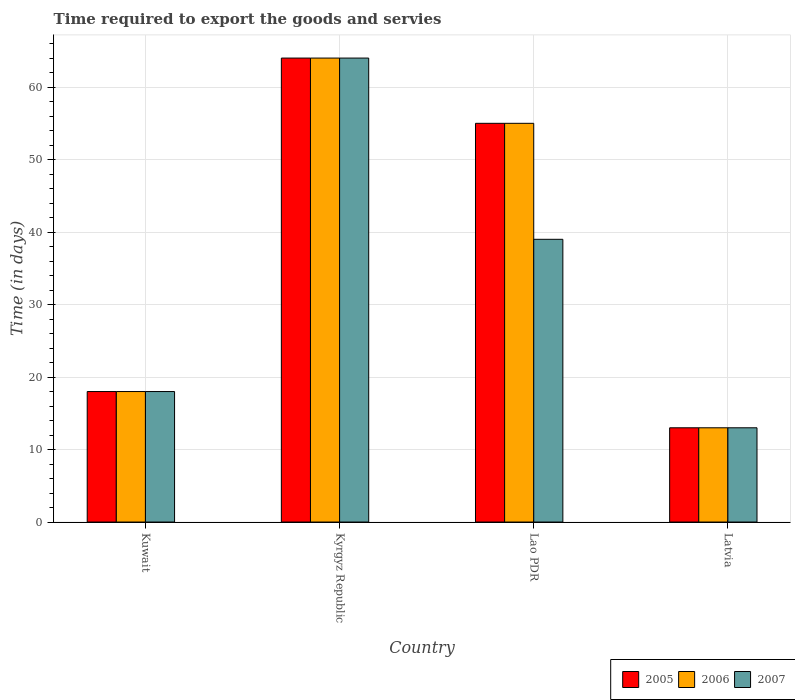How many different coloured bars are there?
Keep it short and to the point. 3. How many groups of bars are there?
Offer a very short reply. 4. Are the number of bars per tick equal to the number of legend labels?
Your response must be concise. Yes. Are the number of bars on each tick of the X-axis equal?
Give a very brief answer. Yes. How many bars are there on the 1st tick from the left?
Your response must be concise. 3. What is the label of the 4th group of bars from the left?
Offer a very short reply. Latvia. What is the number of days required to export the goods and services in 2006 in Lao PDR?
Keep it short and to the point. 55. Across all countries, what is the minimum number of days required to export the goods and services in 2005?
Provide a succinct answer. 13. In which country was the number of days required to export the goods and services in 2006 maximum?
Provide a succinct answer. Kyrgyz Republic. In which country was the number of days required to export the goods and services in 2006 minimum?
Your answer should be very brief. Latvia. What is the total number of days required to export the goods and services in 2007 in the graph?
Keep it short and to the point. 134. What is the difference between the number of days required to export the goods and services in 2006 in Kyrgyz Republic and that in Lao PDR?
Your response must be concise. 9. What is the difference between the number of days required to export the goods and services in 2007 in Latvia and the number of days required to export the goods and services in 2006 in Kyrgyz Republic?
Ensure brevity in your answer.  -51. What is the average number of days required to export the goods and services in 2007 per country?
Offer a terse response. 33.5. What is the difference between the number of days required to export the goods and services of/in 2007 and number of days required to export the goods and services of/in 2005 in Lao PDR?
Your answer should be compact. -16. What is the ratio of the number of days required to export the goods and services in 2007 in Kuwait to that in Latvia?
Offer a very short reply. 1.38. Is the difference between the number of days required to export the goods and services in 2007 in Kuwait and Latvia greater than the difference between the number of days required to export the goods and services in 2005 in Kuwait and Latvia?
Offer a terse response. No. What is the difference between the highest and the second highest number of days required to export the goods and services in 2005?
Ensure brevity in your answer.  46. What is the difference between the highest and the lowest number of days required to export the goods and services in 2005?
Your answer should be compact. 51. In how many countries, is the number of days required to export the goods and services in 2006 greater than the average number of days required to export the goods and services in 2006 taken over all countries?
Offer a very short reply. 2. Is the sum of the number of days required to export the goods and services in 2005 in Kuwait and Lao PDR greater than the maximum number of days required to export the goods and services in 2006 across all countries?
Your answer should be very brief. Yes. What does the 3rd bar from the left in Kyrgyz Republic represents?
Give a very brief answer. 2007. How many bars are there?
Keep it short and to the point. 12. Are all the bars in the graph horizontal?
Ensure brevity in your answer.  No. What is the difference between two consecutive major ticks on the Y-axis?
Your answer should be very brief. 10. Does the graph contain any zero values?
Ensure brevity in your answer.  No. Does the graph contain grids?
Give a very brief answer. Yes. Where does the legend appear in the graph?
Ensure brevity in your answer.  Bottom right. How are the legend labels stacked?
Provide a succinct answer. Horizontal. What is the title of the graph?
Provide a succinct answer. Time required to export the goods and servies. Does "1993" appear as one of the legend labels in the graph?
Your response must be concise. No. What is the label or title of the Y-axis?
Give a very brief answer. Time (in days). What is the Time (in days) in 2005 in Kuwait?
Give a very brief answer. 18. What is the Time (in days) of 2006 in Kuwait?
Your answer should be very brief. 18. What is the Time (in days) in 2007 in Kuwait?
Your response must be concise. 18. What is the Time (in days) in 2005 in Lao PDR?
Your response must be concise. 55. What is the Time (in days) in 2006 in Lao PDR?
Your response must be concise. 55. What is the Time (in days) of 2006 in Latvia?
Offer a very short reply. 13. What is the Time (in days) of 2007 in Latvia?
Your answer should be very brief. 13. Across all countries, what is the maximum Time (in days) in 2007?
Make the answer very short. 64. Across all countries, what is the minimum Time (in days) of 2005?
Give a very brief answer. 13. Across all countries, what is the minimum Time (in days) in 2006?
Your answer should be very brief. 13. What is the total Time (in days) of 2005 in the graph?
Ensure brevity in your answer.  150. What is the total Time (in days) in 2006 in the graph?
Your response must be concise. 150. What is the total Time (in days) of 2007 in the graph?
Keep it short and to the point. 134. What is the difference between the Time (in days) of 2005 in Kuwait and that in Kyrgyz Republic?
Offer a very short reply. -46. What is the difference between the Time (in days) in 2006 in Kuwait and that in Kyrgyz Republic?
Keep it short and to the point. -46. What is the difference between the Time (in days) of 2007 in Kuwait and that in Kyrgyz Republic?
Keep it short and to the point. -46. What is the difference between the Time (in days) of 2005 in Kuwait and that in Lao PDR?
Give a very brief answer. -37. What is the difference between the Time (in days) of 2006 in Kuwait and that in Lao PDR?
Offer a very short reply. -37. What is the difference between the Time (in days) in 2007 in Kuwait and that in Lao PDR?
Make the answer very short. -21. What is the difference between the Time (in days) of 2006 in Kuwait and that in Latvia?
Ensure brevity in your answer.  5. What is the difference between the Time (in days) in 2005 in Kyrgyz Republic and that in Lao PDR?
Make the answer very short. 9. What is the difference between the Time (in days) in 2007 in Kyrgyz Republic and that in Lao PDR?
Offer a very short reply. 25. What is the difference between the Time (in days) of 2005 in Kyrgyz Republic and that in Latvia?
Your answer should be compact. 51. What is the difference between the Time (in days) of 2006 in Kyrgyz Republic and that in Latvia?
Offer a terse response. 51. What is the difference between the Time (in days) of 2007 in Lao PDR and that in Latvia?
Keep it short and to the point. 26. What is the difference between the Time (in days) of 2005 in Kuwait and the Time (in days) of 2006 in Kyrgyz Republic?
Offer a terse response. -46. What is the difference between the Time (in days) of 2005 in Kuwait and the Time (in days) of 2007 in Kyrgyz Republic?
Ensure brevity in your answer.  -46. What is the difference between the Time (in days) in 2006 in Kuwait and the Time (in days) in 2007 in Kyrgyz Republic?
Offer a terse response. -46. What is the difference between the Time (in days) of 2005 in Kuwait and the Time (in days) of 2006 in Lao PDR?
Provide a succinct answer. -37. What is the difference between the Time (in days) of 2005 in Kuwait and the Time (in days) of 2007 in Lao PDR?
Offer a very short reply. -21. What is the difference between the Time (in days) in 2006 in Kuwait and the Time (in days) in 2007 in Lao PDR?
Your answer should be very brief. -21. What is the difference between the Time (in days) of 2006 in Kuwait and the Time (in days) of 2007 in Latvia?
Provide a succinct answer. 5. What is the difference between the Time (in days) of 2005 in Kyrgyz Republic and the Time (in days) of 2006 in Lao PDR?
Offer a very short reply. 9. What is the difference between the Time (in days) in 2005 in Kyrgyz Republic and the Time (in days) in 2006 in Latvia?
Make the answer very short. 51. What is the difference between the Time (in days) of 2006 in Kyrgyz Republic and the Time (in days) of 2007 in Latvia?
Provide a short and direct response. 51. What is the difference between the Time (in days) of 2005 in Lao PDR and the Time (in days) of 2007 in Latvia?
Keep it short and to the point. 42. What is the difference between the Time (in days) of 2006 in Lao PDR and the Time (in days) of 2007 in Latvia?
Keep it short and to the point. 42. What is the average Time (in days) of 2005 per country?
Provide a short and direct response. 37.5. What is the average Time (in days) in 2006 per country?
Your answer should be very brief. 37.5. What is the average Time (in days) of 2007 per country?
Offer a very short reply. 33.5. What is the difference between the Time (in days) in 2005 and Time (in days) in 2006 in Kuwait?
Your answer should be very brief. 0. What is the difference between the Time (in days) in 2005 and Time (in days) in 2007 in Kuwait?
Offer a terse response. 0. What is the difference between the Time (in days) of 2006 and Time (in days) of 2007 in Kuwait?
Make the answer very short. 0. What is the difference between the Time (in days) in 2005 and Time (in days) in 2006 in Kyrgyz Republic?
Provide a short and direct response. 0. What is the difference between the Time (in days) of 2005 and Time (in days) of 2007 in Kyrgyz Republic?
Your response must be concise. 0. What is the difference between the Time (in days) of 2006 and Time (in days) of 2007 in Kyrgyz Republic?
Ensure brevity in your answer.  0. What is the difference between the Time (in days) of 2005 and Time (in days) of 2007 in Lao PDR?
Your answer should be very brief. 16. What is the difference between the Time (in days) of 2005 and Time (in days) of 2006 in Latvia?
Offer a very short reply. 0. What is the difference between the Time (in days) of 2006 and Time (in days) of 2007 in Latvia?
Your answer should be compact. 0. What is the ratio of the Time (in days) of 2005 in Kuwait to that in Kyrgyz Republic?
Provide a succinct answer. 0.28. What is the ratio of the Time (in days) in 2006 in Kuwait to that in Kyrgyz Republic?
Offer a very short reply. 0.28. What is the ratio of the Time (in days) of 2007 in Kuwait to that in Kyrgyz Republic?
Make the answer very short. 0.28. What is the ratio of the Time (in days) in 2005 in Kuwait to that in Lao PDR?
Your answer should be very brief. 0.33. What is the ratio of the Time (in days) of 2006 in Kuwait to that in Lao PDR?
Offer a very short reply. 0.33. What is the ratio of the Time (in days) in 2007 in Kuwait to that in Lao PDR?
Ensure brevity in your answer.  0.46. What is the ratio of the Time (in days) of 2005 in Kuwait to that in Latvia?
Provide a succinct answer. 1.38. What is the ratio of the Time (in days) in 2006 in Kuwait to that in Latvia?
Offer a terse response. 1.38. What is the ratio of the Time (in days) of 2007 in Kuwait to that in Latvia?
Your response must be concise. 1.38. What is the ratio of the Time (in days) in 2005 in Kyrgyz Republic to that in Lao PDR?
Provide a succinct answer. 1.16. What is the ratio of the Time (in days) of 2006 in Kyrgyz Republic to that in Lao PDR?
Keep it short and to the point. 1.16. What is the ratio of the Time (in days) of 2007 in Kyrgyz Republic to that in Lao PDR?
Your response must be concise. 1.64. What is the ratio of the Time (in days) of 2005 in Kyrgyz Republic to that in Latvia?
Give a very brief answer. 4.92. What is the ratio of the Time (in days) of 2006 in Kyrgyz Republic to that in Latvia?
Make the answer very short. 4.92. What is the ratio of the Time (in days) in 2007 in Kyrgyz Republic to that in Latvia?
Provide a short and direct response. 4.92. What is the ratio of the Time (in days) in 2005 in Lao PDR to that in Latvia?
Offer a very short reply. 4.23. What is the ratio of the Time (in days) of 2006 in Lao PDR to that in Latvia?
Provide a succinct answer. 4.23. What is the ratio of the Time (in days) of 2007 in Lao PDR to that in Latvia?
Keep it short and to the point. 3. What is the difference between the highest and the second highest Time (in days) of 2005?
Provide a succinct answer. 9. 